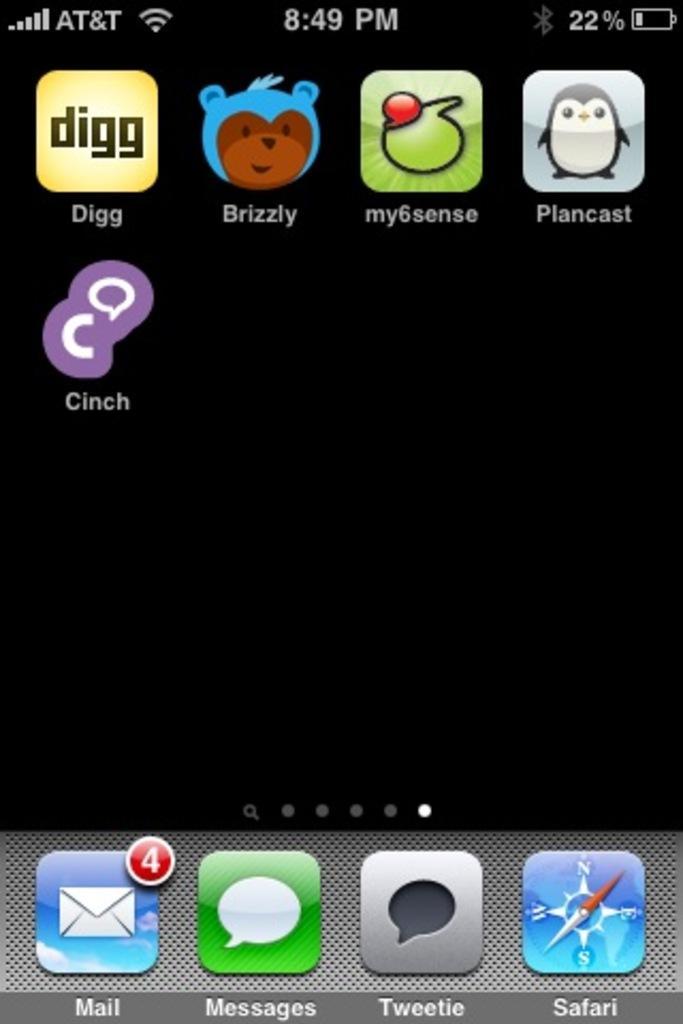Describe this image in one or two sentences. In this image we can see the screen of a mobile. In this screen, we can see there are a few apps, below the apps there is some text, at the top of the image we can see the percentage of the battery, time and WiFi connection. 